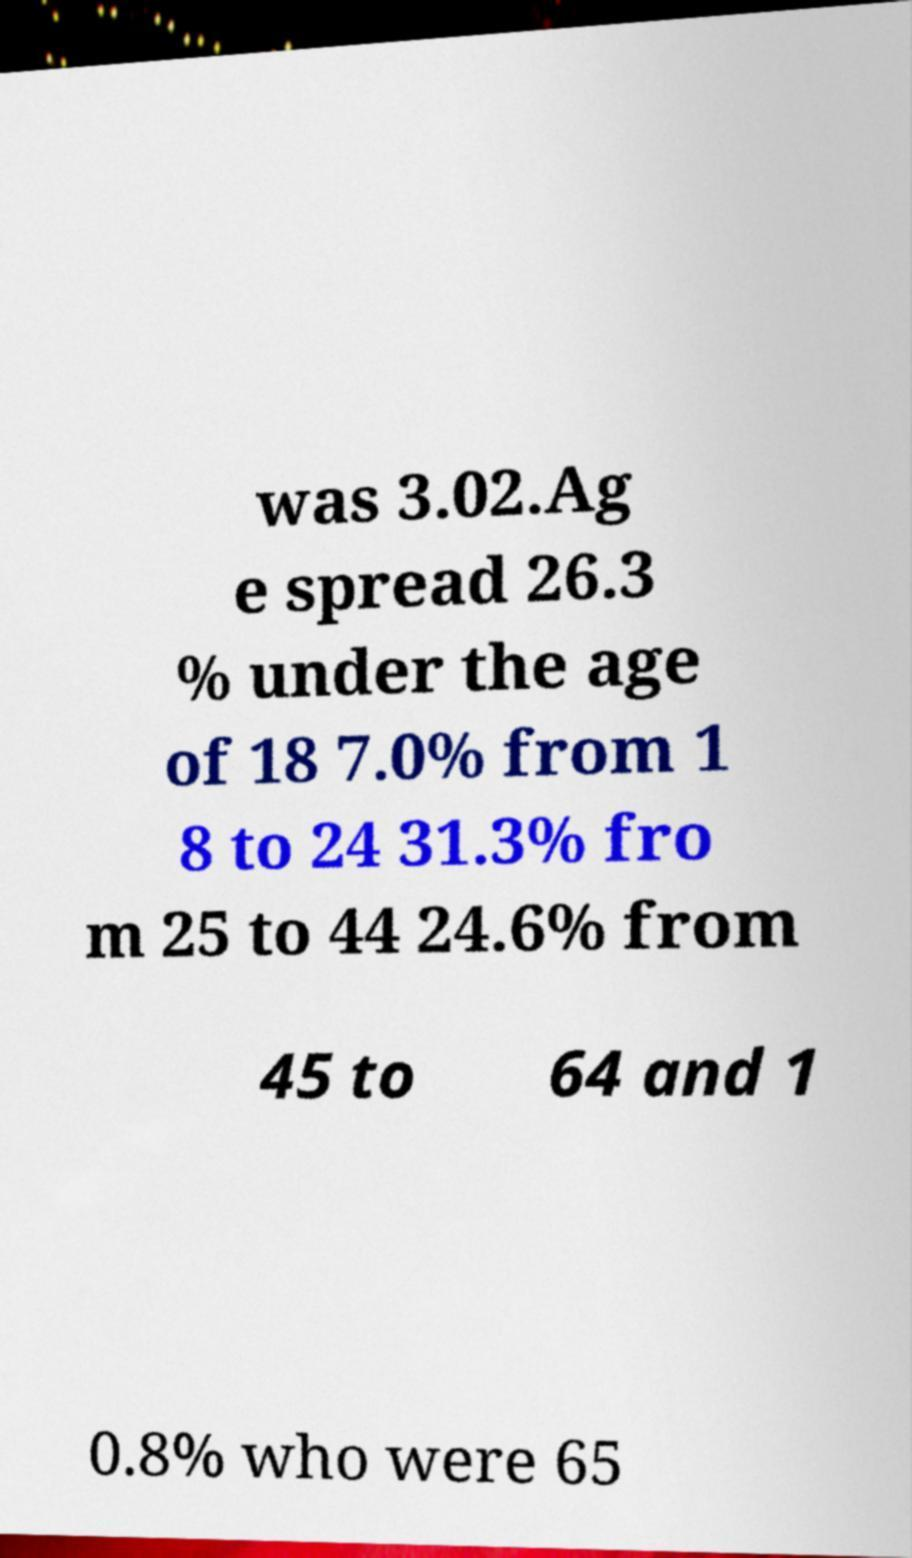I need the written content from this picture converted into text. Can you do that? was 3.02.Ag e spread 26.3 % under the age of 18 7.0% from 1 8 to 24 31.3% fro m 25 to 44 24.6% from 45 to 64 and 1 0.8% who were 65 